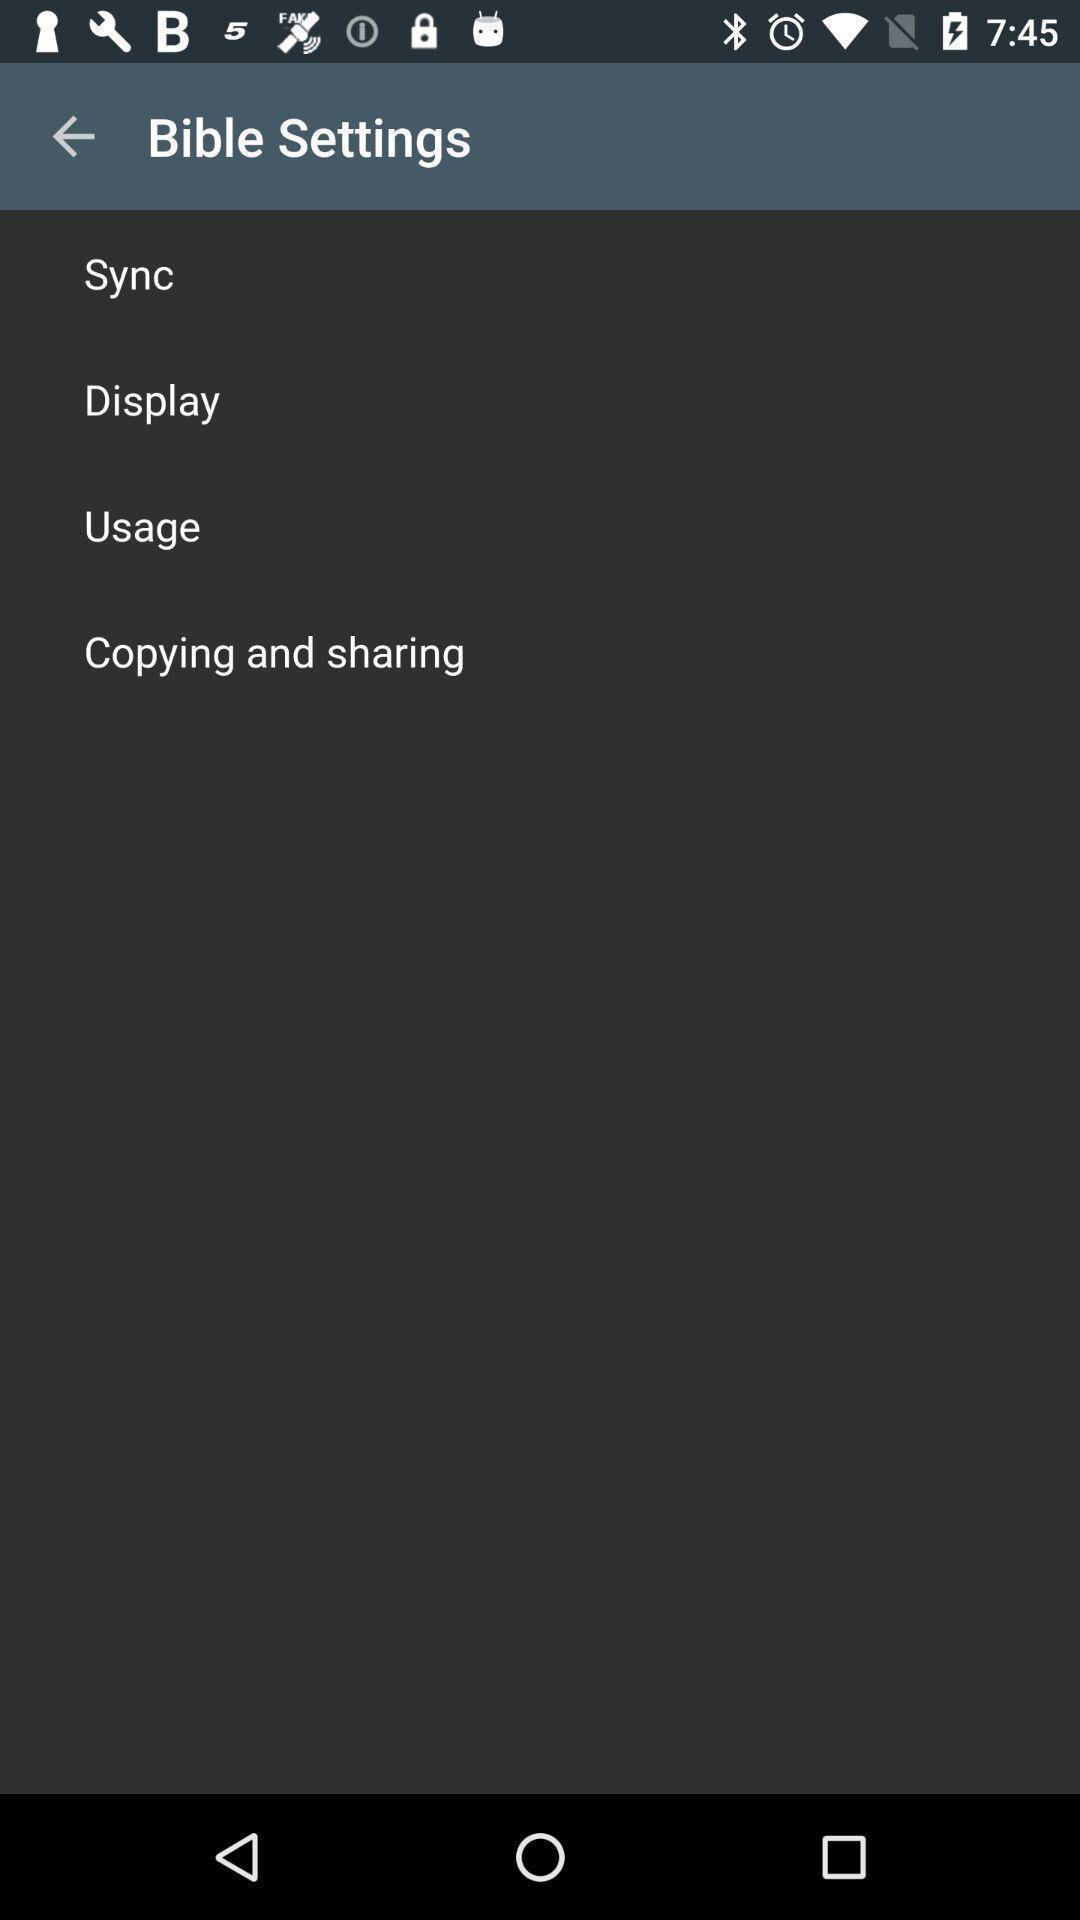Summarize the information in this screenshot. Settings page showing. 